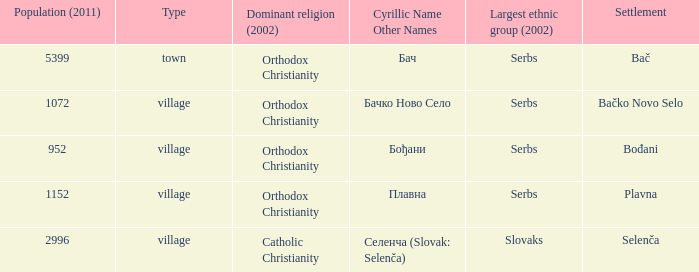What is the smallest population listed? 952.0. 